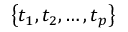<formula> <loc_0><loc_0><loc_500><loc_500>\left \{ t _ { 1 } , t _ { 2 } , \dots , t _ { p } \right \}</formula> 